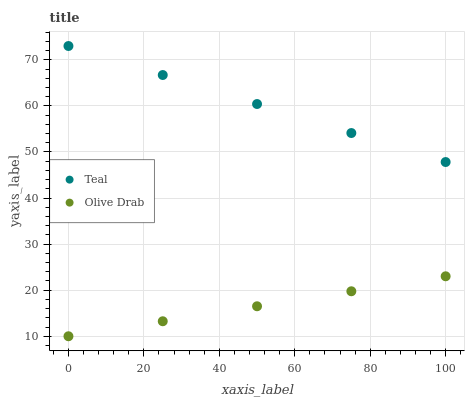Does Olive Drab have the minimum area under the curve?
Answer yes or no. Yes. Does Teal have the maximum area under the curve?
Answer yes or no. Yes. Does Teal have the minimum area under the curve?
Answer yes or no. No. Is Olive Drab the smoothest?
Answer yes or no. Yes. Is Teal the roughest?
Answer yes or no. Yes. Is Teal the smoothest?
Answer yes or no. No. Does Olive Drab have the lowest value?
Answer yes or no. Yes. Does Teal have the lowest value?
Answer yes or no. No. Does Teal have the highest value?
Answer yes or no. Yes. Is Olive Drab less than Teal?
Answer yes or no. Yes. Is Teal greater than Olive Drab?
Answer yes or no. Yes. Does Olive Drab intersect Teal?
Answer yes or no. No. 